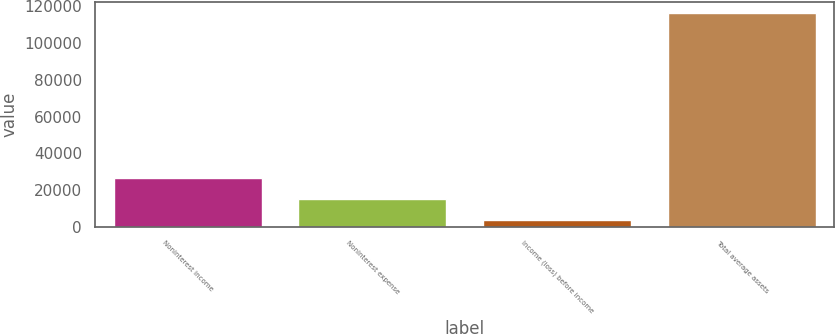Convert chart. <chart><loc_0><loc_0><loc_500><loc_500><bar_chart><fcel>Noninterest income<fcel>Noninterest expense<fcel>Income (loss) before income<fcel>Total average assets<nl><fcel>26360.5<fcel>15063<fcel>3715<fcel>116690<nl></chart> 